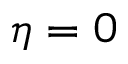<formula> <loc_0><loc_0><loc_500><loc_500>\eta = 0</formula> 